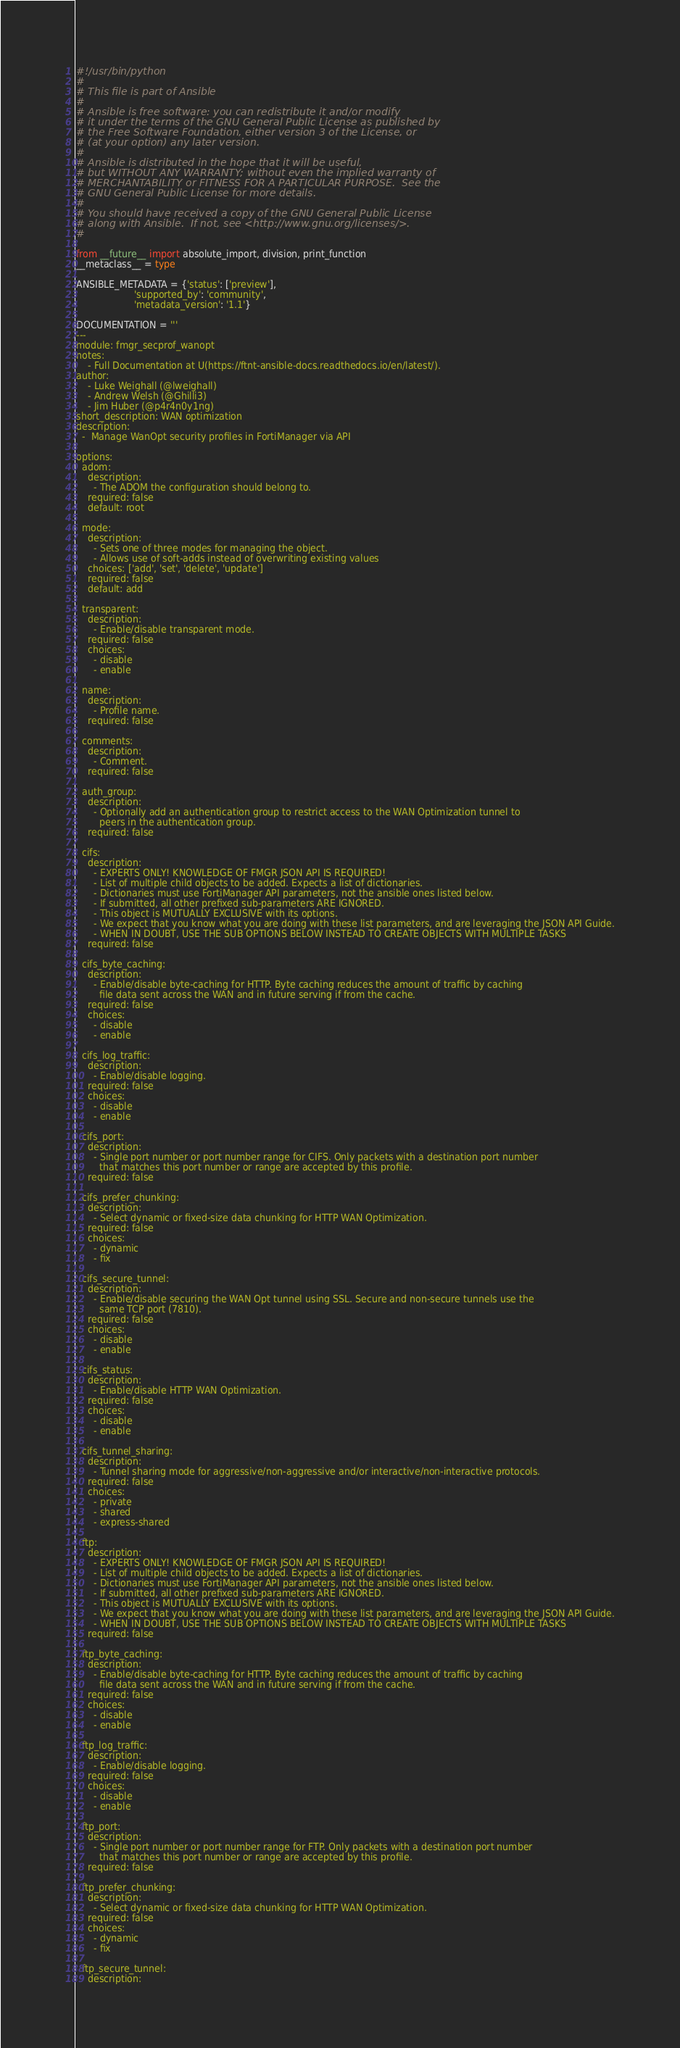Convert code to text. <code><loc_0><loc_0><loc_500><loc_500><_Python_>#!/usr/bin/python
#
# This file is part of Ansible
#
# Ansible is free software: you can redistribute it and/or modify
# it under the terms of the GNU General Public License as published by
# the Free Software Foundation, either version 3 of the License, or
# (at your option) any later version.
#
# Ansible is distributed in the hope that it will be useful,
# but WITHOUT ANY WARRANTY; without even the implied warranty of
# MERCHANTABILITY or FITNESS FOR A PARTICULAR PURPOSE.  See the
# GNU General Public License for more details.
#
# You should have received a copy of the GNU General Public License
# along with Ansible.  If not, see <http://www.gnu.org/licenses/>.
#

from __future__ import absolute_import, division, print_function
__metaclass__ = type

ANSIBLE_METADATA = {'status': ['preview'],
                    'supported_by': 'community',
                    'metadata_version': '1.1'}

DOCUMENTATION = '''
---
module: fmgr_secprof_wanopt
notes:
    - Full Documentation at U(https://ftnt-ansible-docs.readthedocs.io/en/latest/).
author:
    - Luke Weighall (@lweighall)
    - Andrew Welsh (@Ghilli3)
    - Jim Huber (@p4r4n0y1ng)
short_description: WAN optimization
description:
  -  Manage WanOpt security profiles in FortiManager via API

options:
  adom:
    description:
      - The ADOM the configuration should belong to.
    required: false
    default: root

  mode:
    description:
      - Sets one of three modes for managing the object.
      - Allows use of soft-adds instead of overwriting existing values
    choices: ['add', 'set', 'delete', 'update']
    required: false
    default: add

  transparent:
    description:
      - Enable/disable transparent mode.
    required: false
    choices:
      - disable
      - enable

  name:
    description:
      - Profile name.
    required: false

  comments:
    description:
      - Comment.
    required: false

  auth_group:
    description:
      - Optionally add an authentication group to restrict access to the WAN Optimization tunnel to
        peers in the authentication group.
    required: false

  cifs:
    description:
      - EXPERTS ONLY! KNOWLEDGE OF FMGR JSON API IS REQUIRED!
      - List of multiple child objects to be added. Expects a list of dictionaries.
      - Dictionaries must use FortiManager API parameters, not the ansible ones listed below.
      - If submitted, all other prefixed sub-parameters ARE IGNORED.
      - This object is MUTUALLY EXCLUSIVE with its options.
      - We expect that you know what you are doing with these list parameters, and are leveraging the JSON API Guide.
      - WHEN IN DOUBT, USE THE SUB OPTIONS BELOW INSTEAD TO CREATE OBJECTS WITH MULTIPLE TASKS
    required: false

  cifs_byte_caching:
    description:
      - Enable/disable byte-caching for HTTP. Byte caching reduces the amount of traffic by caching
        file data sent across the WAN and in future serving if from the cache.
    required: false
    choices:
      - disable
      - enable

  cifs_log_traffic:
    description:
      - Enable/disable logging.
    required: false
    choices:
      - disable
      - enable

  cifs_port:
    description:
      - Single port number or port number range for CIFS. Only packets with a destination port number
        that matches this port number or range are accepted by this profile.
    required: false

  cifs_prefer_chunking:
    description:
      - Select dynamic or fixed-size data chunking for HTTP WAN Optimization.
    required: false
    choices:
      - dynamic
      - fix

  cifs_secure_tunnel:
    description:
      - Enable/disable securing the WAN Opt tunnel using SSL. Secure and non-secure tunnels use the
        same TCP port (7810).
    required: false
    choices:
      - disable
      - enable

  cifs_status:
    description:
      - Enable/disable HTTP WAN Optimization.
    required: false
    choices:
      - disable
      - enable

  cifs_tunnel_sharing:
    description:
      - Tunnel sharing mode for aggressive/non-aggressive and/or interactive/non-interactive protocols.
    required: false
    choices:
      - private
      - shared
      - express-shared

  ftp:
    description:
      - EXPERTS ONLY! KNOWLEDGE OF FMGR JSON API IS REQUIRED!
      - List of multiple child objects to be added. Expects a list of dictionaries.
      - Dictionaries must use FortiManager API parameters, not the ansible ones listed below.
      - If submitted, all other prefixed sub-parameters ARE IGNORED.
      - This object is MUTUALLY EXCLUSIVE with its options.
      - We expect that you know what you are doing with these list parameters, and are leveraging the JSON API Guide.
      - WHEN IN DOUBT, USE THE SUB OPTIONS BELOW INSTEAD TO CREATE OBJECTS WITH MULTIPLE TASKS
    required: false

  ftp_byte_caching:
    description:
      - Enable/disable byte-caching for HTTP. Byte caching reduces the amount of traffic by caching
        file data sent across the WAN and in future serving if from the cache.
    required: false
    choices:
      - disable
      - enable

  ftp_log_traffic:
    description:
      - Enable/disable logging.
    required: false
    choices:
      - disable
      - enable

  ftp_port:
    description:
      - Single port number or port number range for FTP. Only packets with a destination port number
        that matches this port number or range are accepted by this profile.
    required: false

  ftp_prefer_chunking:
    description:
      - Select dynamic or fixed-size data chunking for HTTP WAN Optimization.
    required: false
    choices:
      - dynamic
      - fix

  ftp_secure_tunnel:
    description:</code> 